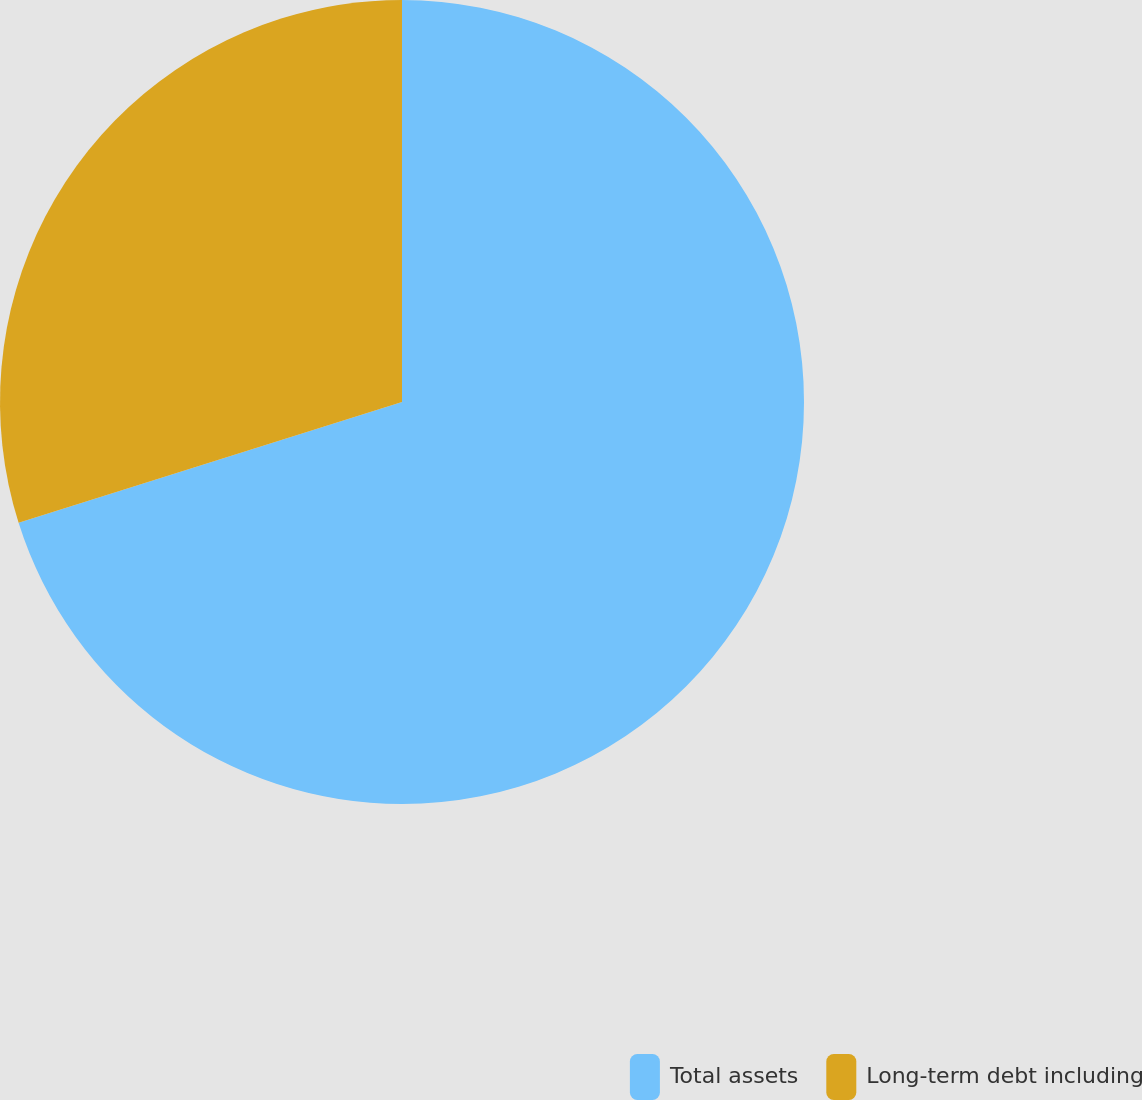Convert chart. <chart><loc_0><loc_0><loc_500><loc_500><pie_chart><fcel>Total assets<fcel>Long-term debt including<nl><fcel>70.14%<fcel>29.86%<nl></chart> 